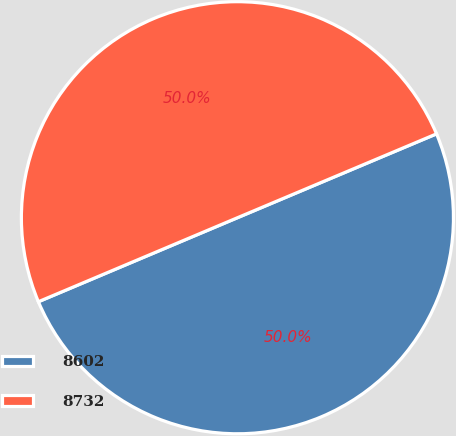Convert chart. <chart><loc_0><loc_0><loc_500><loc_500><pie_chart><fcel>8602<fcel>8732<nl><fcel>49.99%<fcel>50.01%<nl></chart> 